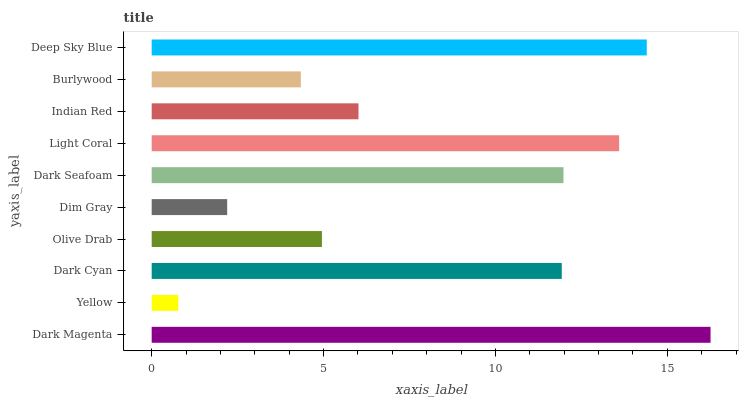Is Yellow the minimum?
Answer yes or no. Yes. Is Dark Magenta the maximum?
Answer yes or no. Yes. Is Dark Cyan the minimum?
Answer yes or no. No. Is Dark Cyan the maximum?
Answer yes or no. No. Is Dark Cyan greater than Yellow?
Answer yes or no. Yes. Is Yellow less than Dark Cyan?
Answer yes or no. Yes. Is Yellow greater than Dark Cyan?
Answer yes or no. No. Is Dark Cyan less than Yellow?
Answer yes or no. No. Is Dark Cyan the high median?
Answer yes or no. Yes. Is Indian Red the low median?
Answer yes or no. Yes. Is Deep Sky Blue the high median?
Answer yes or no. No. Is Dark Magenta the low median?
Answer yes or no. No. 